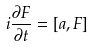Convert formula to latex. <formula><loc_0><loc_0><loc_500><loc_500>i \frac { \partial F } { \partial t } = [ a , F ]</formula> 